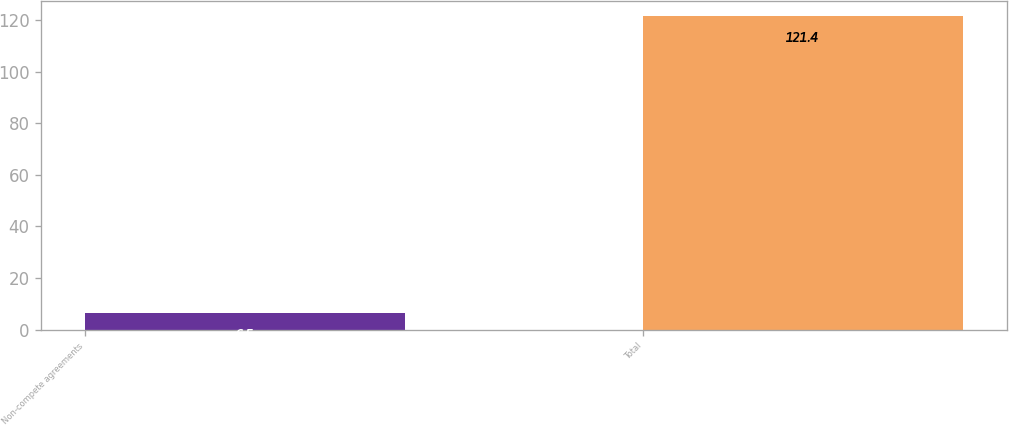<chart> <loc_0><loc_0><loc_500><loc_500><bar_chart><fcel>Non-compete agreements<fcel>Total<nl><fcel>6.5<fcel>121.4<nl></chart> 